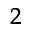<formula> <loc_0><loc_0><loc_500><loc_500>^ { 2 }</formula> 